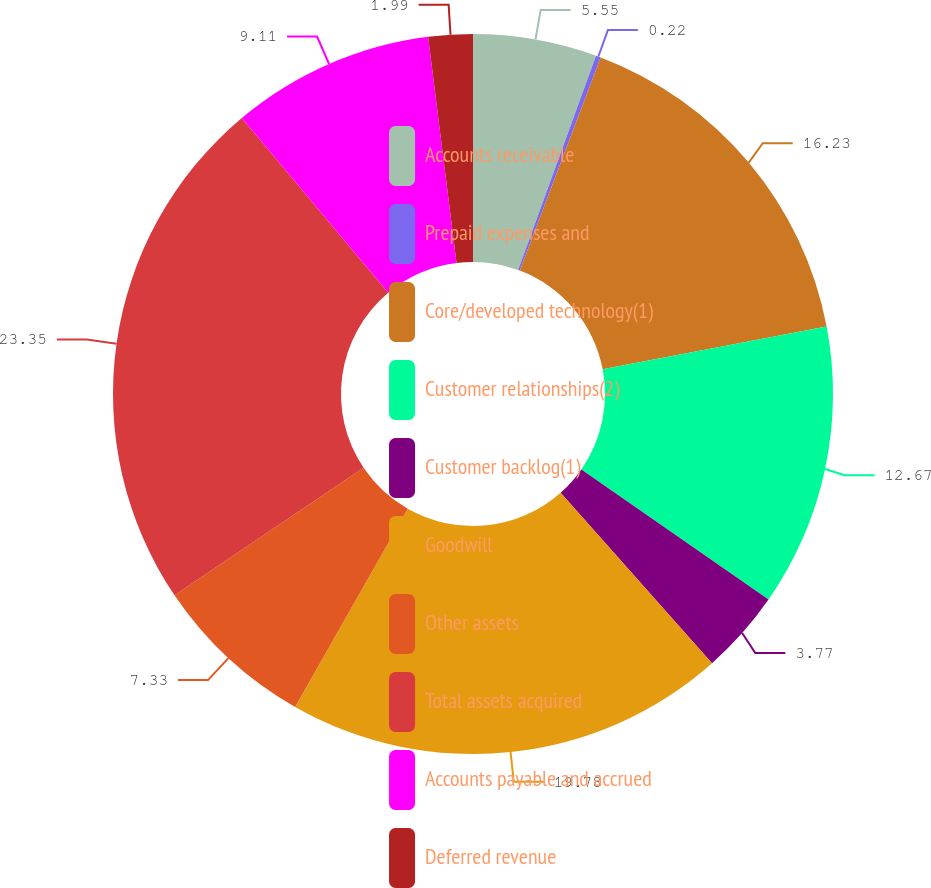Convert chart. <chart><loc_0><loc_0><loc_500><loc_500><pie_chart><fcel>Accounts receivable<fcel>Prepaid expenses and<fcel>Core/developed technology(1)<fcel>Customer relationships(2)<fcel>Customer backlog(1)<fcel>Goodwill<fcel>Other assets<fcel>Total assets acquired<fcel>Accounts payable and accrued<fcel>Deferred revenue<nl><fcel>5.55%<fcel>0.22%<fcel>16.23%<fcel>12.67%<fcel>3.77%<fcel>19.78%<fcel>7.33%<fcel>23.34%<fcel>9.11%<fcel>1.99%<nl></chart> 